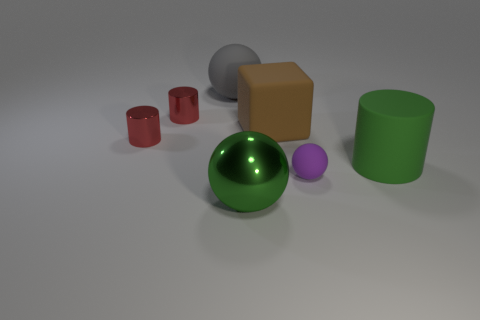What is the material of the large gray object that is the same shape as the big green shiny object?
Provide a succinct answer. Rubber. Is the size of the rubber sphere in front of the rubber cylinder the same as the thing to the right of the small purple thing?
Provide a succinct answer. No. What number of other objects are the same size as the green rubber thing?
Give a very brief answer. 3. What is the material of the big thing on the left side of the large green thing in front of the cylinder to the right of the tiny purple matte object?
Ensure brevity in your answer.  Rubber. There is a metallic ball; is it the same size as the ball that is on the left side of the big green metallic thing?
Your answer should be compact. Yes. What is the size of the matte thing that is in front of the brown rubber block and behind the small matte thing?
Provide a succinct answer. Large. Are there any other tiny matte balls of the same color as the tiny matte ball?
Give a very brief answer. No. What is the color of the tiny thing that is right of the thing that is in front of the purple ball?
Offer a very short reply. Purple. Are there fewer rubber cylinders that are to the left of the large gray matte sphere than large green rubber objects on the left side of the shiny sphere?
Your response must be concise. No. Do the gray rubber thing and the green matte object have the same size?
Ensure brevity in your answer.  Yes. 